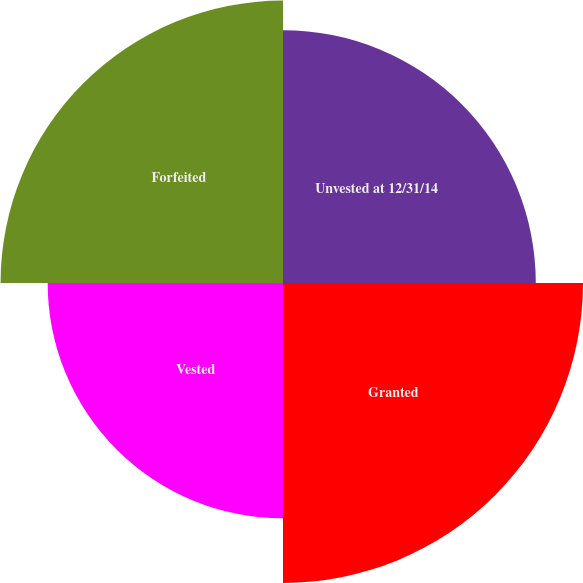Convert chart to OTSL. <chart><loc_0><loc_0><loc_500><loc_500><pie_chart><fcel>Unvested at 12/31/14<fcel>Granted<fcel>Vested<fcel>Forfeited<nl><fcel>23.61%<fcel>28.02%<fcel>21.98%<fcel>26.38%<nl></chart> 